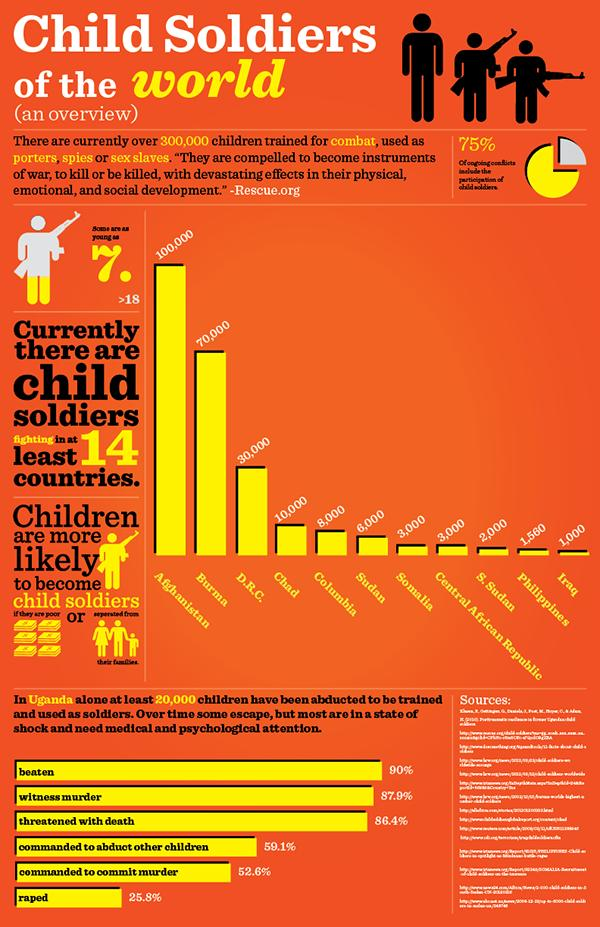Indicate a few pertinent items in this graphic. The fifth highest number of child soldiers are present in Colombia. It is reported that in Somalia, the seventh-highest number of child soldiers are present. Child abduction is the second-most common purpose of witness murder. Burma has the second-highest number of child soldiers present in any country. According to estimates, approximately 9,000 child soldiers are currently present in the combined territories of Sudan and Somalia. 